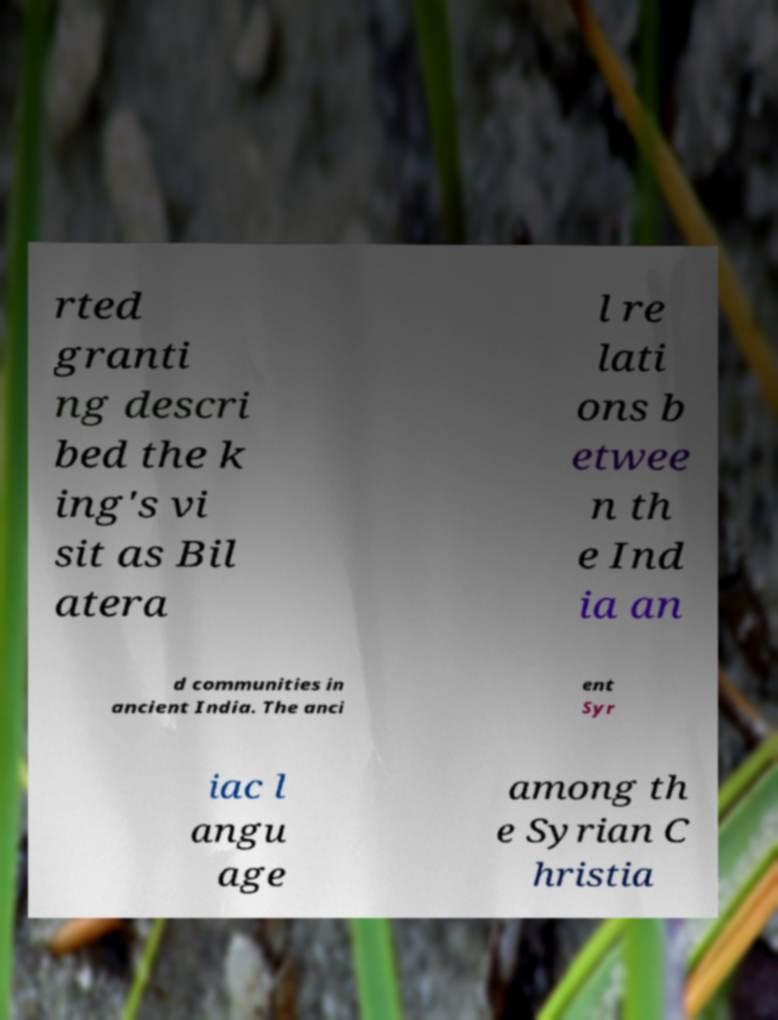Could you extract and type out the text from this image? rted granti ng descri bed the k ing's vi sit as Bil atera l re lati ons b etwee n th e Ind ia an d communities in ancient India. The anci ent Syr iac l angu age among th e Syrian C hristia 